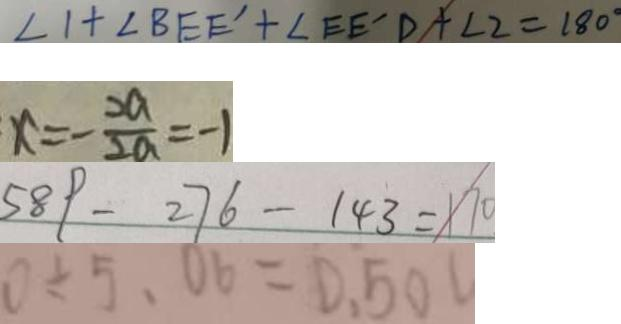Convert formula to latex. <formula><loc_0><loc_0><loc_500><loc_500>\angle 1 + \angle B E E ^ { \prime } + \angle E E ^ { \prime } D + \angle 2 = 1 8 0 ^ { \circ } 
 x = - \frac { 2 a } { 2 a } = - 1 
 5 8 9 - 2 7 6 - 1 4 3 = 1 7 0 
 0 \div 5 、 0 6 = 0 . 5 0</formula> 